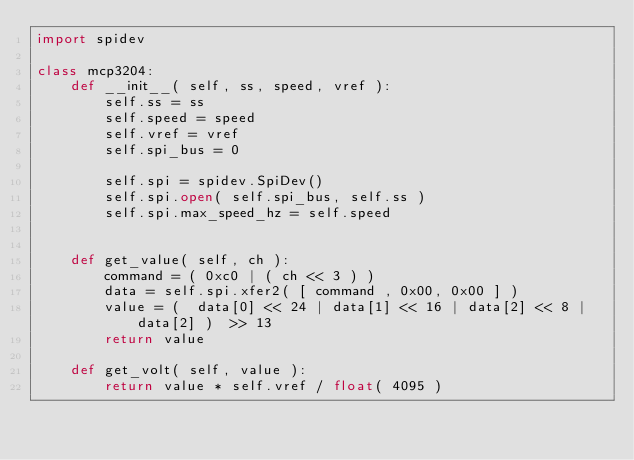Convert code to text. <code><loc_0><loc_0><loc_500><loc_500><_Python_>import spidev

class mcp3204:
    def __init__( self, ss, speed, vref ):
        self.ss = ss
        self.speed = speed
        self.vref = vref
        self.spi_bus = 0
        
        self.spi = spidev.SpiDev()
        self.spi.open( self.spi_bus, self.ss )
        self.spi.max_speed_hz = self.speed
        
        
    def get_value( self, ch ):
        command = ( 0xc0 | ( ch << 3 ) ) 
        data = self.spi.xfer2( [ command , 0x00, 0x00 ] )
        value = (  data[0] << 24 | data[1] << 16 | data[2] << 8 | data[2] )  >> 13
        return value

    def get_volt( self, value ):
        return value * self.vref / float( 4095 )


</code> 